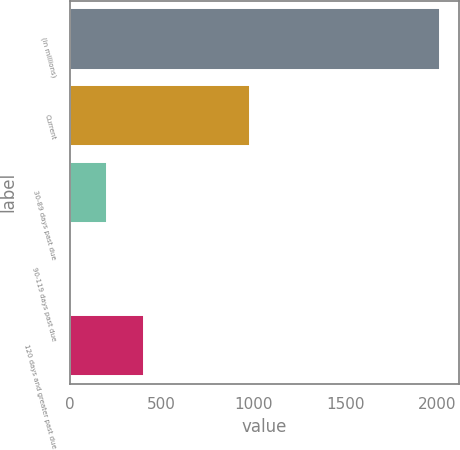Convert chart to OTSL. <chart><loc_0><loc_0><loc_500><loc_500><bar_chart><fcel>(in millions)<fcel>Current<fcel>30-89 days past due<fcel>90-119 days past due<fcel>120 days and greater past due<nl><fcel>2014<fcel>980<fcel>203.2<fcel>2<fcel>404.4<nl></chart> 